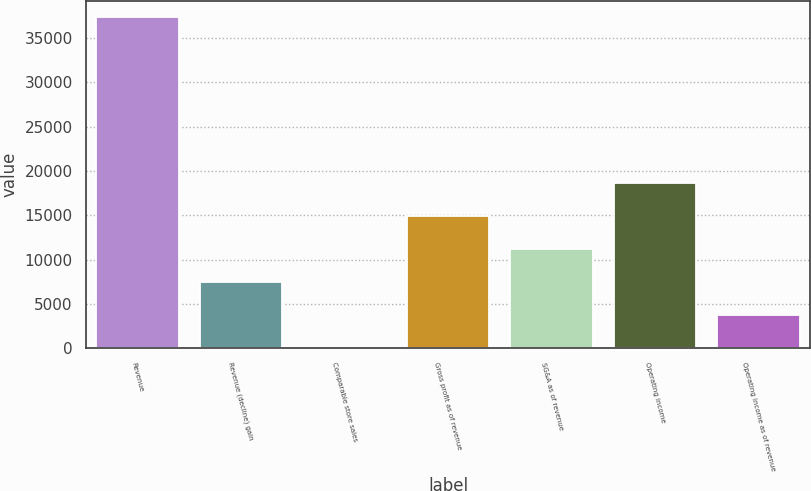Convert chart. <chart><loc_0><loc_0><loc_500><loc_500><bar_chart><fcel>Revenue<fcel>Revenue (decline) gain<fcel>Comparable store sales<fcel>Gross profit as of revenue<fcel>SG&A as of revenue<fcel>Operating income<fcel>Operating income as of revenue<nl><fcel>37314<fcel>7464.16<fcel>1.7<fcel>14926.6<fcel>11195.4<fcel>18657.8<fcel>3732.93<nl></chart> 